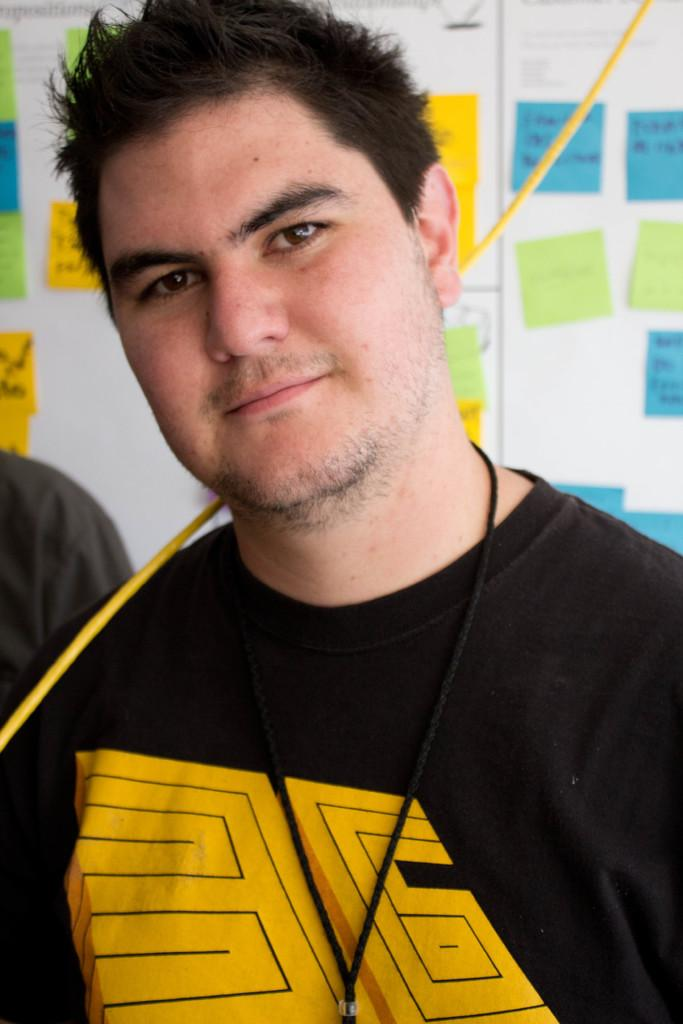How many people are in the image? There are two persons standing in the image. Where are the persons standing? The persons are standing on the floor. What can be seen in the background of the image? There is a notice board in the background of the image. What is attached to the notice board? Papers are attached to the notice board. What type of lace can be seen on the persons' clothing in the image? There is no lace visible on the persons' clothing in the image. Can you describe the celery used in the image's background design? There is no celery present in the image, nor is there any background design mentioned in the facts. 